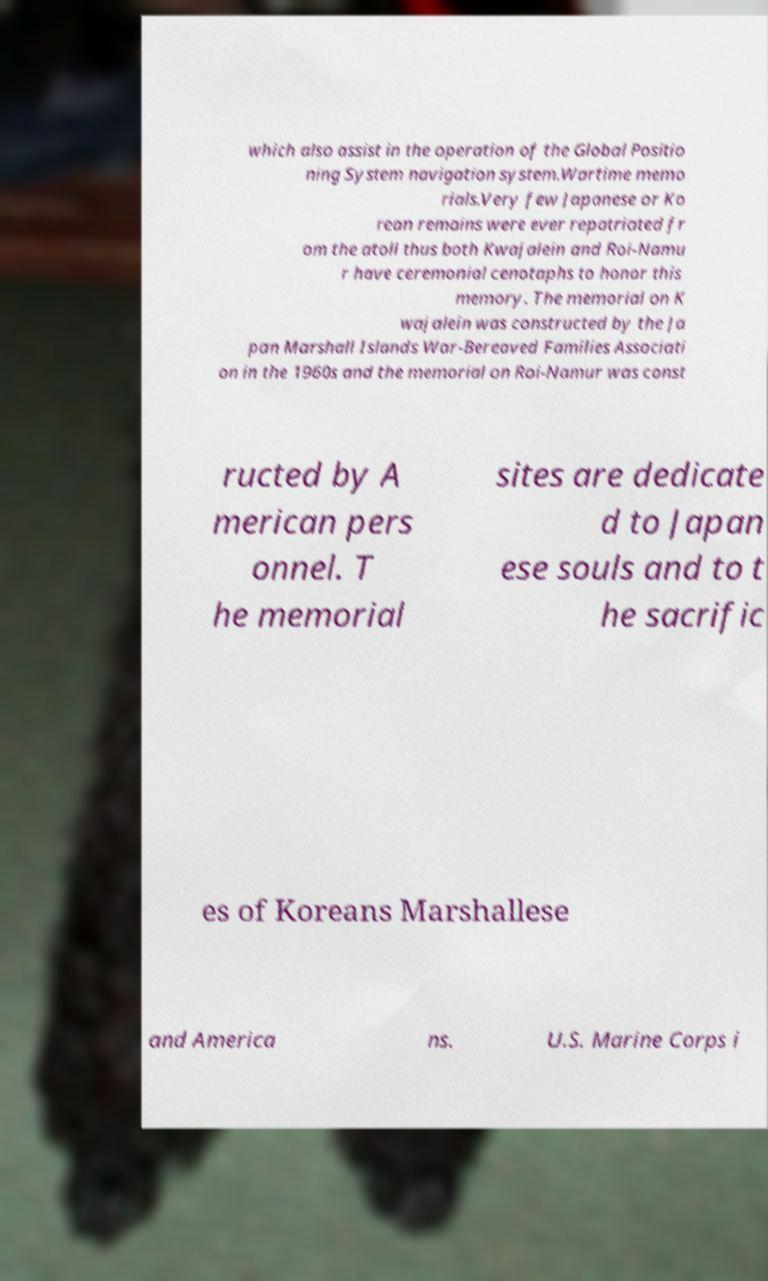Could you extract and type out the text from this image? which also assist in the operation of the Global Positio ning System navigation system.Wartime memo rials.Very few Japanese or Ko rean remains were ever repatriated fr om the atoll thus both Kwajalein and Roi-Namu r have ceremonial cenotaphs to honor this memory. The memorial on K wajalein was constructed by the Ja pan Marshall Islands War-Bereaved Families Associati on in the 1960s and the memorial on Roi-Namur was const ructed by A merican pers onnel. T he memorial sites are dedicate d to Japan ese souls and to t he sacrific es of Koreans Marshallese and America ns. U.S. Marine Corps i 